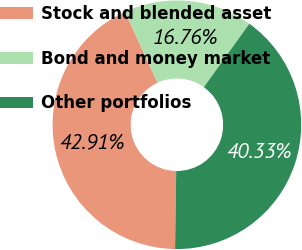<chart> <loc_0><loc_0><loc_500><loc_500><pie_chart><fcel>Stock and blended asset<fcel>Bond and money market<fcel>Other portfolios<nl><fcel>42.91%<fcel>16.76%<fcel>40.33%<nl></chart> 